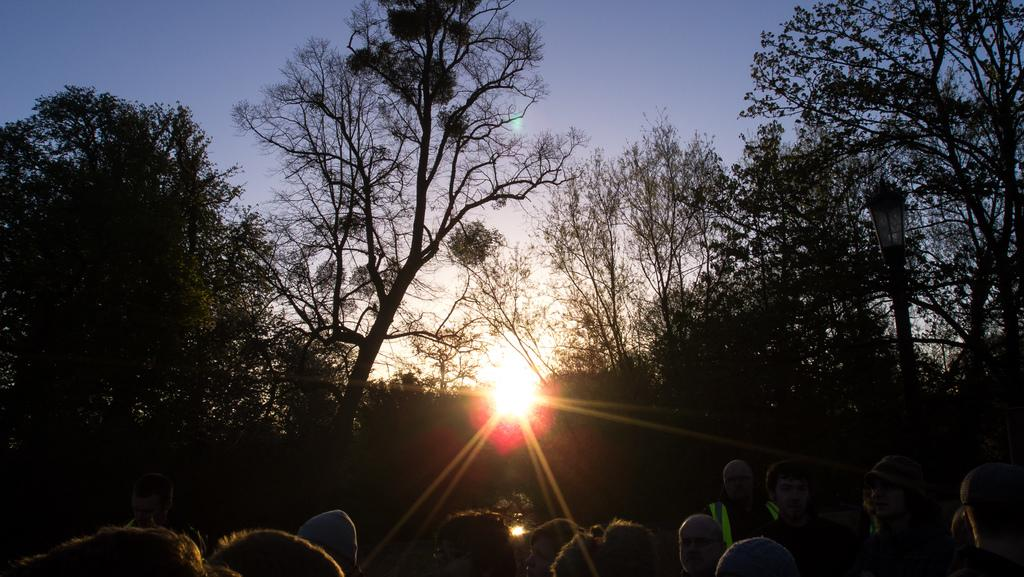What type of natural vegetation is present in the image? There is a group of trees in the image. What can be seen in the sky behind the trees? The sun is visible in the sky behind the trees. Are there any people or animals in the image? Yes, there are persons in the image. What type of caption is written on the image? There is no caption present in the image. What government policy is being discussed in the image? The image does not depict any government policy or discussion. 